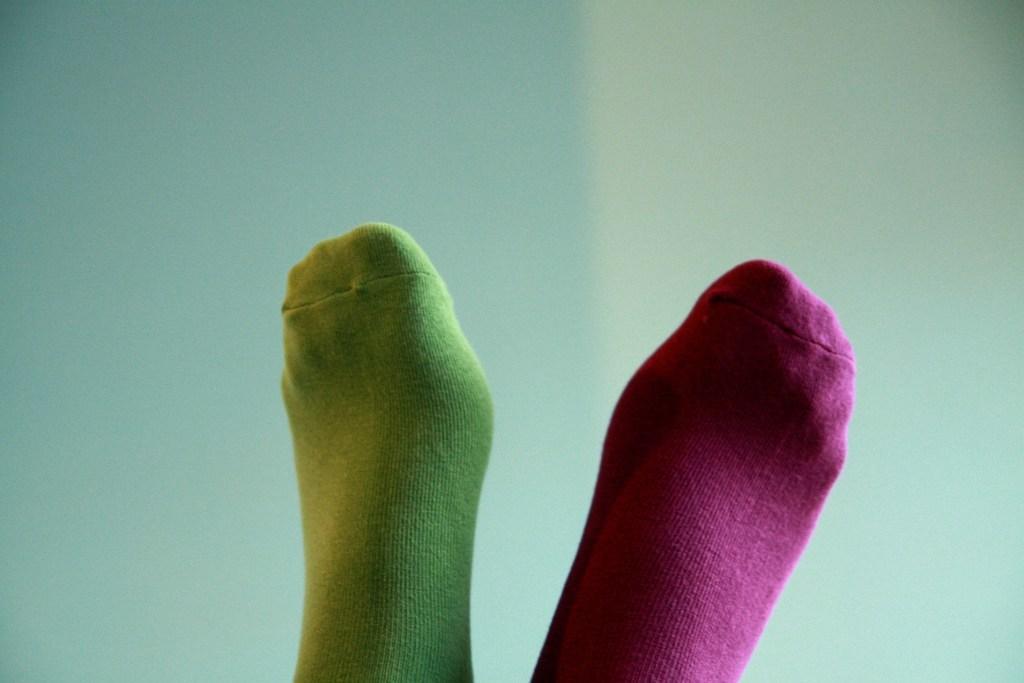Describe this image in one or two sentences. In this picture they look like human legs with socks in the middle. In the background it may be the wall. 